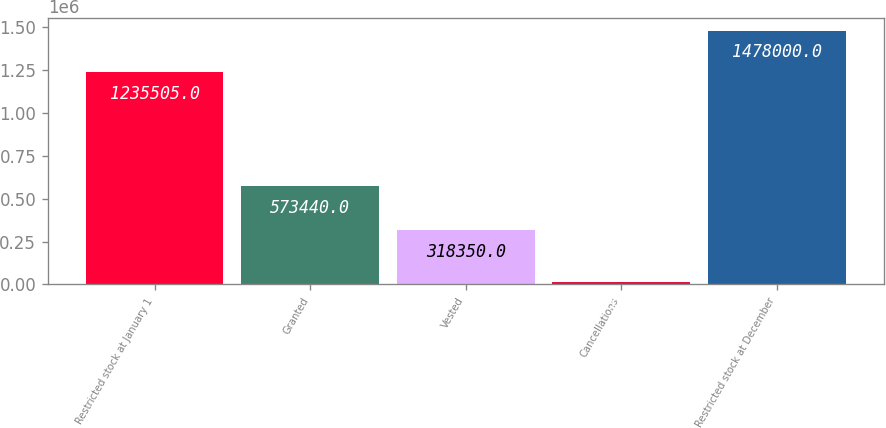Convert chart to OTSL. <chart><loc_0><loc_0><loc_500><loc_500><bar_chart><fcel>Restricted stock at January 1<fcel>Granted<fcel>Vested<fcel>Cancellations<fcel>Restricted stock at December<nl><fcel>1.2355e+06<fcel>573440<fcel>318350<fcel>12595<fcel>1.478e+06<nl></chart> 